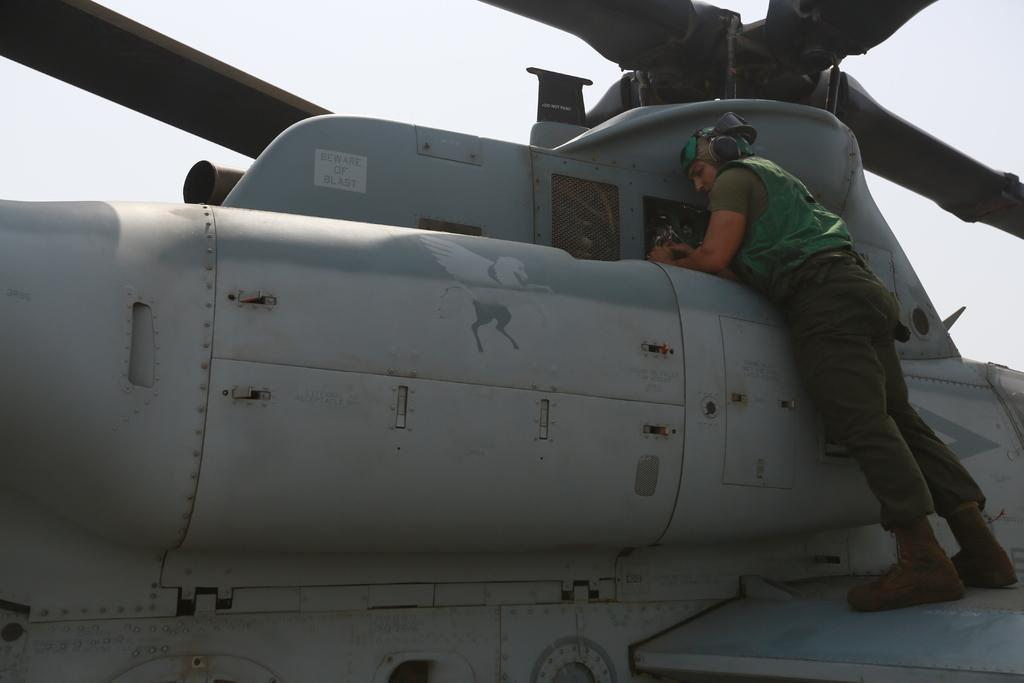What type of view is shown in the image? The image has an outside view. Can you describe the person in the foreground of the image? The person is in the foreground of the image and is wearing clothes. What is the person doing in the image? The person is standing on a helicopter. What can be seen in the background of the image? There is a sky visible in the background of the image. What type of record is being played by the bee in the image? There is no bee or record present in the image. 